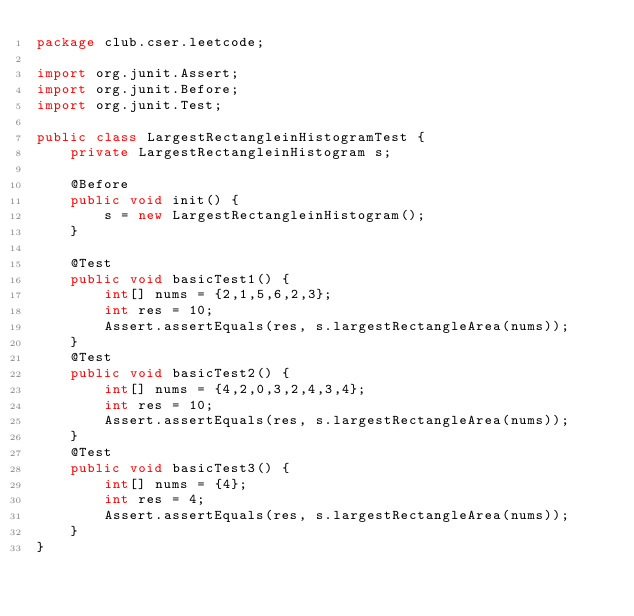<code> <loc_0><loc_0><loc_500><loc_500><_Java_>package club.cser.leetcode;

import org.junit.Assert;
import org.junit.Before;
import org.junit.Test;

public class LargestRectangleinHistogramTest {
    private LargestRectangleinHistogram s;

    @Before
    public void init() {
        s = new LargestRectangleinHistogram();
    }

    @Test
    public void basicTest1() {
        int[] nums = {2,1,5,6,2,3};
        int res = 10;
        Assert.assertEquals(res, s.largestRectangleArea(nums));
    }
    @Test
    public void basicTest2() {
        int[] nums = {4,2,0,3,2,4,3,4};
        int res = 10;
        Assert.assertEquals(res, s.largestRectangleArea(nums));
    }
    @Test
    public void basicTest3() {
        int[] nums = {4};
        int res = 4;
        Assert.assertEquals(res, s.largestRectangleArea(nums));
    }
}
</code> 